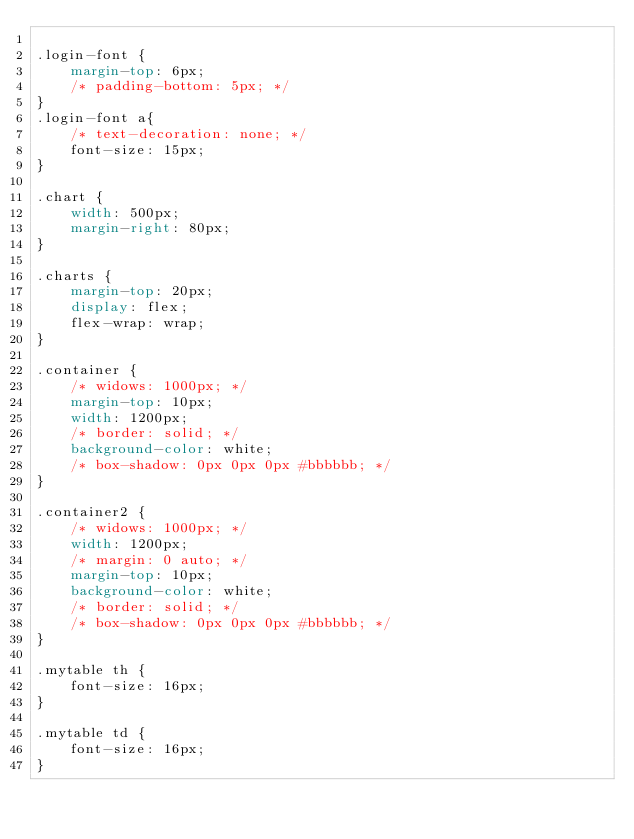Convert code to text. <code><loc_0><loc_0><loc_500><loc_500><_CSS_>
.login-font {
    margin-top: 6px;
    /* padding-bottom: 5px; */
}
.login-font a{
    /* text-decoration: none; */
    font-size: 15px;
}

.chart {
    width: 500px;
    margin-right: 80px;
}

.charts {
    margin-top: 20px;
    display: flex;
    flex-wrap: wrap;
}

.container {
    /* widows: 1000px; */
    margin-top: 10px;
    width: 1200px;
    /* border: solid; */
    background-color: white;
    /* box-shadow: 0px 0px 0px #bbbbbb; */
}

.container2 {
    /* widows: 1000px; */
    width: 1200px;
    /* margin: 0 auto; */
    margin-top: 10px;
    background-color: white;
    /* border: solid; */
    /* box-shadow: 0px 0px 0px #bbbbbb; */
}

.mytable th {
    font-size: 16px;
}

.mytable td {
    font-size: 16px;
}
</code> 